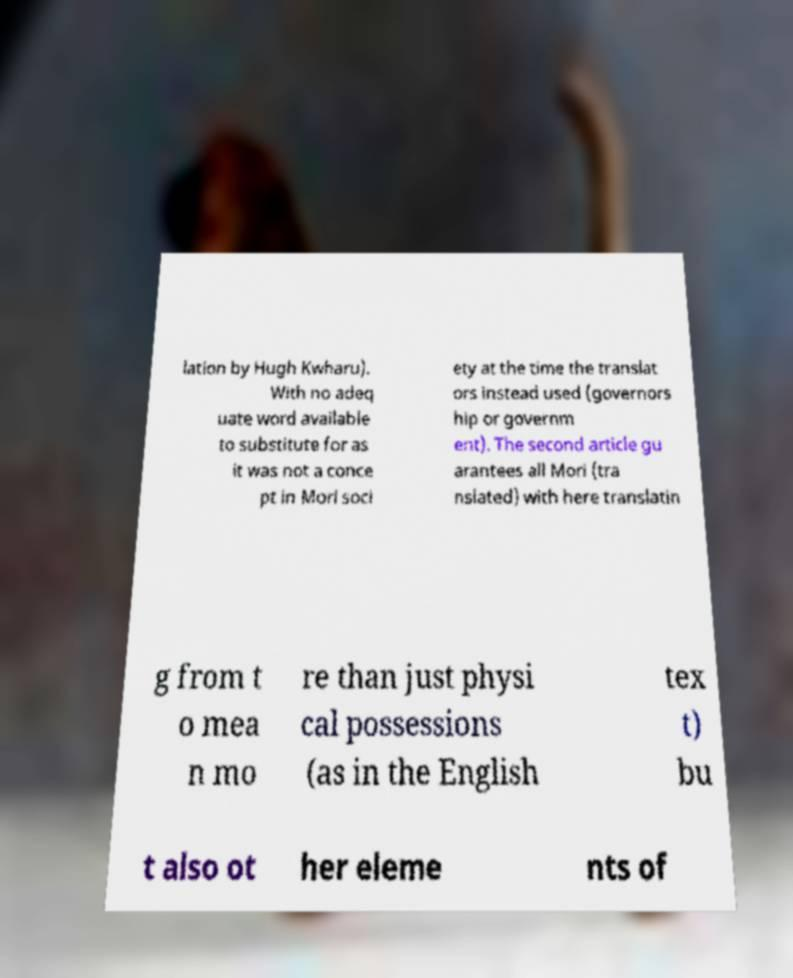What messages or text are displayed in this image? I need them in a readable, typed format. lation by Hugh Kwharu). With no adeq uate word available to substitute for as it was not a conce pt in Mori soci ety at the time the translat ors instead used (governors hip or governm ent). The second article gu arantees all Mori (tra nslated) with here translatin g from t o mea n mo re than just physi cal possessions (as in the English tex t) bu t also ot her eleme nts of 